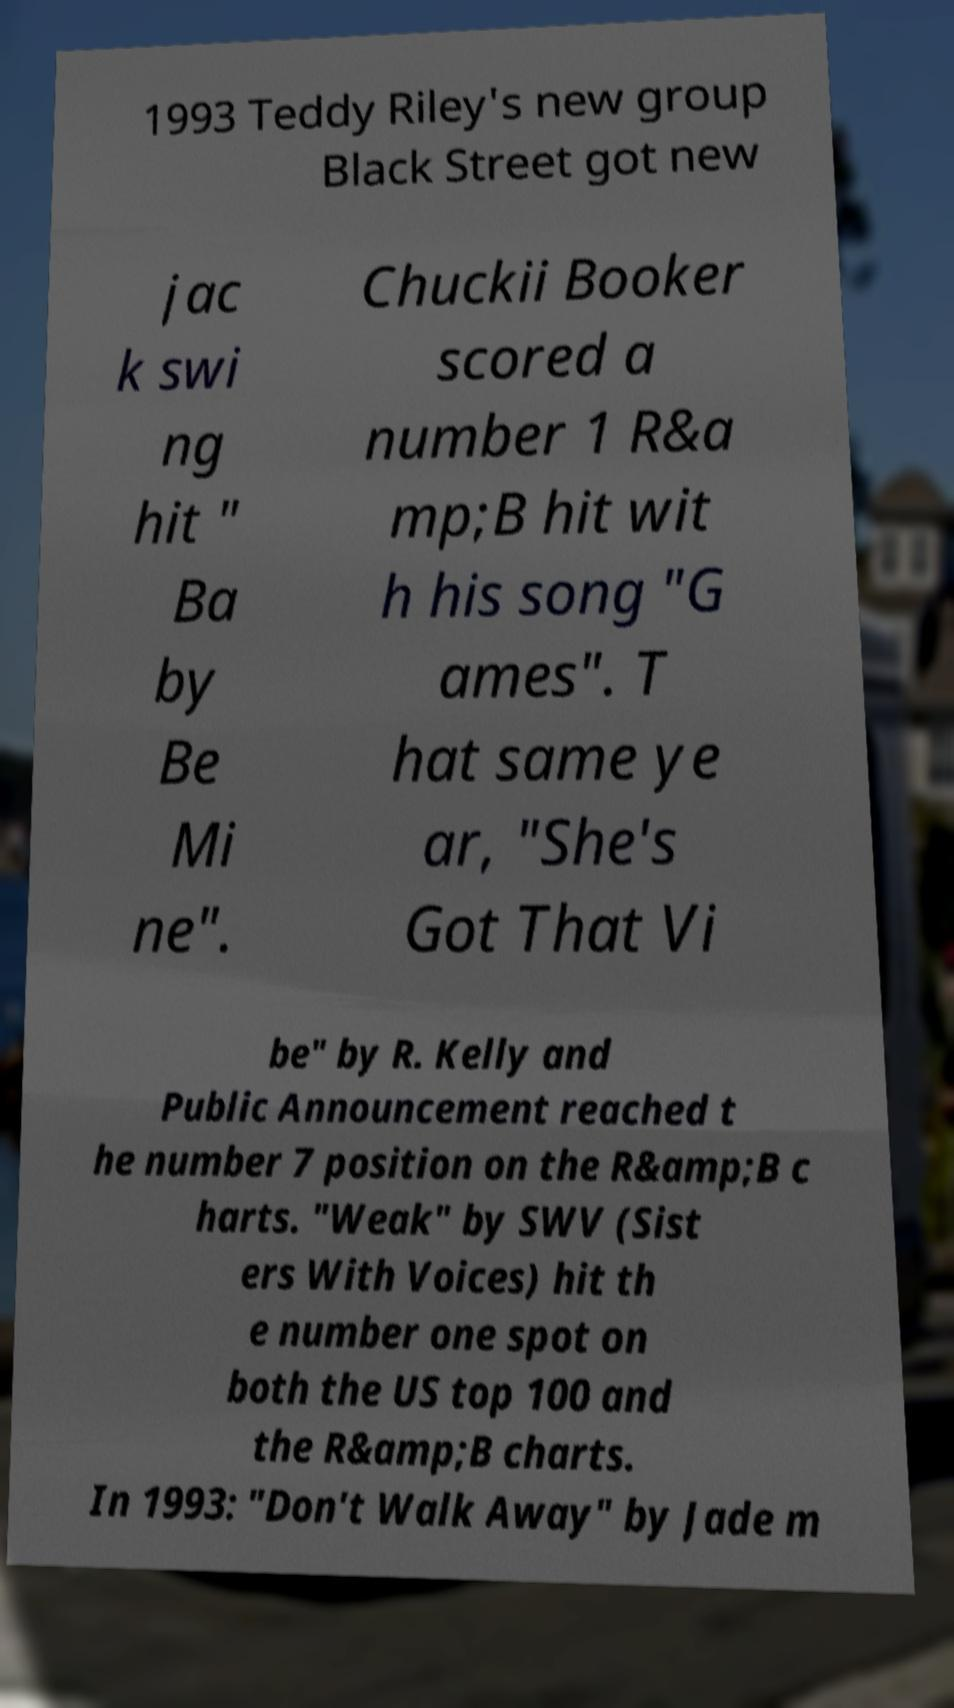I need the written content from this picture converted into text. Can you do that? 1993 Teddy Riley's new group Black Street got new jac k swi ng hit " Ba by Be Mi ne". Chuckii Booker scored a number 1 R&a mp;B hit wit h his song "G ames". T hat same ye ar, "She's Got That Vi be" by R. Kelly and Public Announcement reached t he number 7 position on the R&amp;B c harts. "Weak" by SWV (Sist ers With Voices) hit th e number one spot on both the US top 100 and the R&amp;B charts. In 1993: "Don't Walk Away" by Jade m 